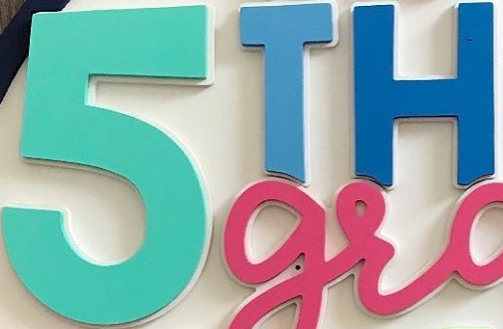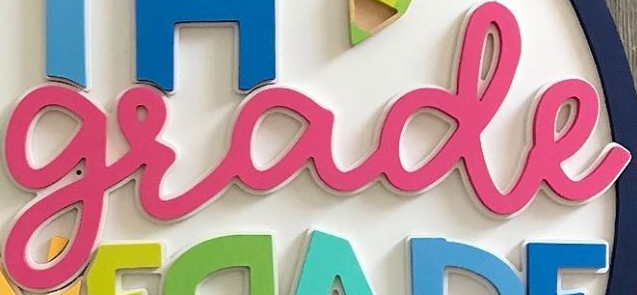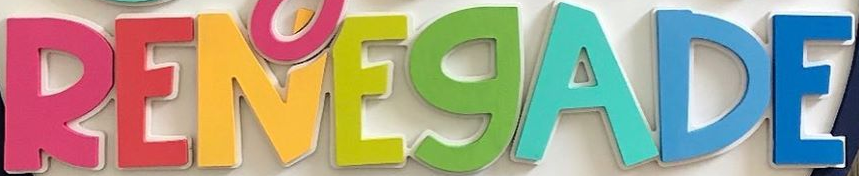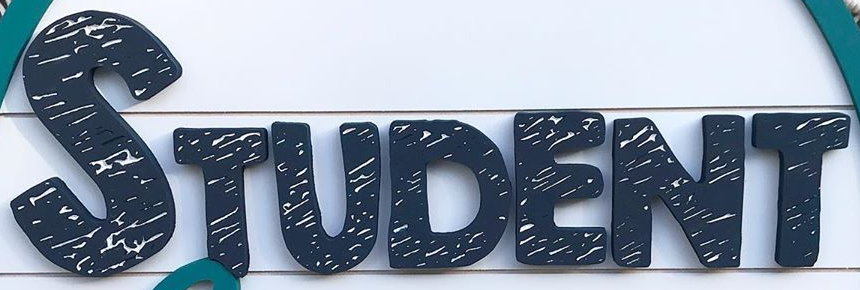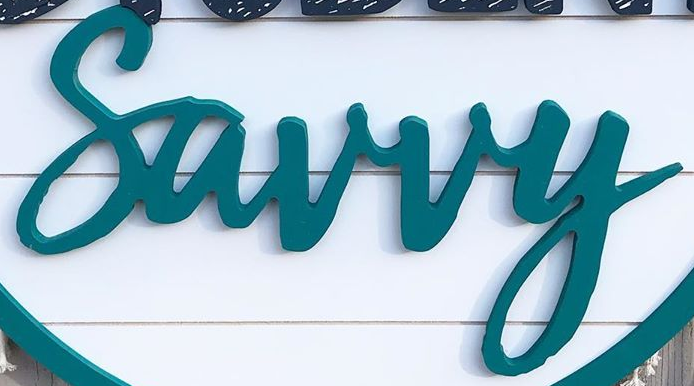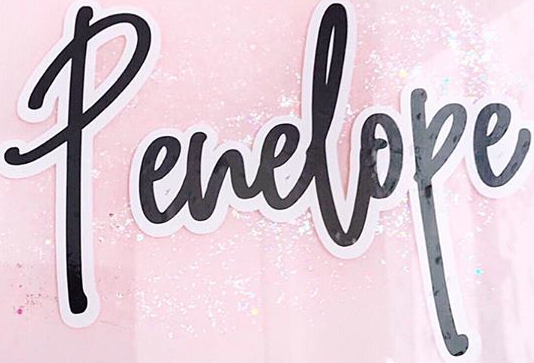What text is displayed in these images sequentially, separated by a semicolon? 5TH; grade; RENEGADE; STUDENT; Surry; Penelope 